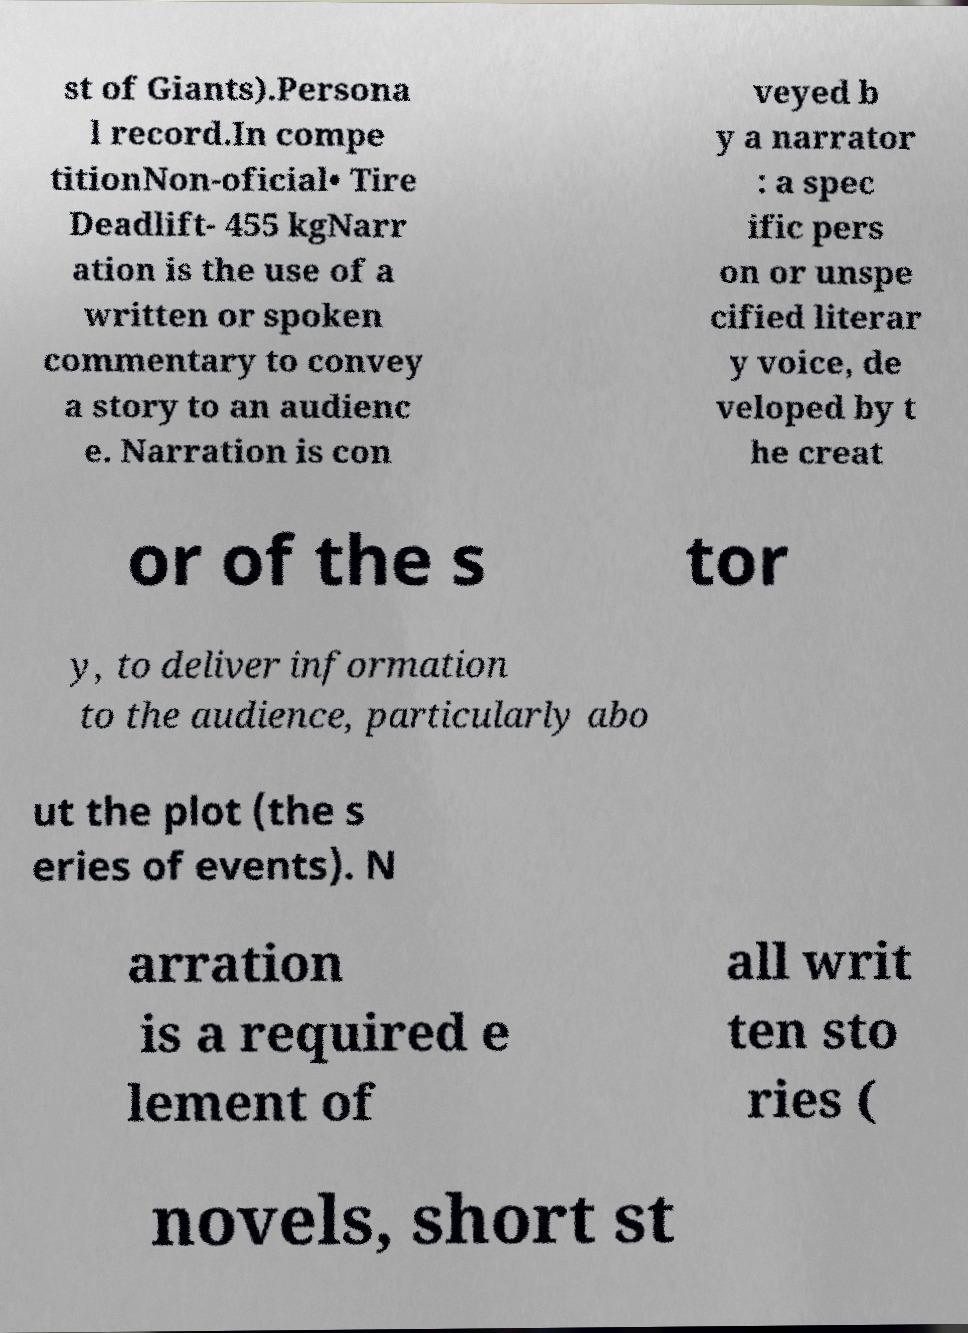Can you read and provide the text displayed in the image?This photo seems to have some interesting text. Can you extract and type it out for me? st of Giants).Persona l record.In compe titionNon-oficial• Tire Deadlift- 455 kgNarr ation is the use of a written or spoken commentary to convey a story to an audienc e. Narration is con veyed b y a narrator : a spec ific pers on or unspe cified literar y voice, de veloped by t he creat or of the s tor y, to deliver information to the audience, particularly abo ut the plot (the s eries of events). N arration is a required e lement of all writ ten sto ries ( novels, short st 